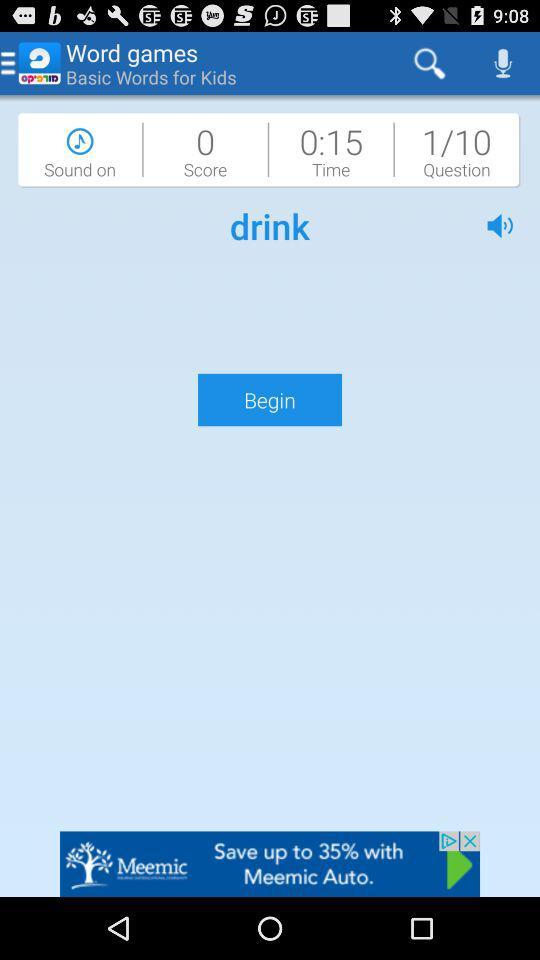What is the application name? The application name is "Morfix". 